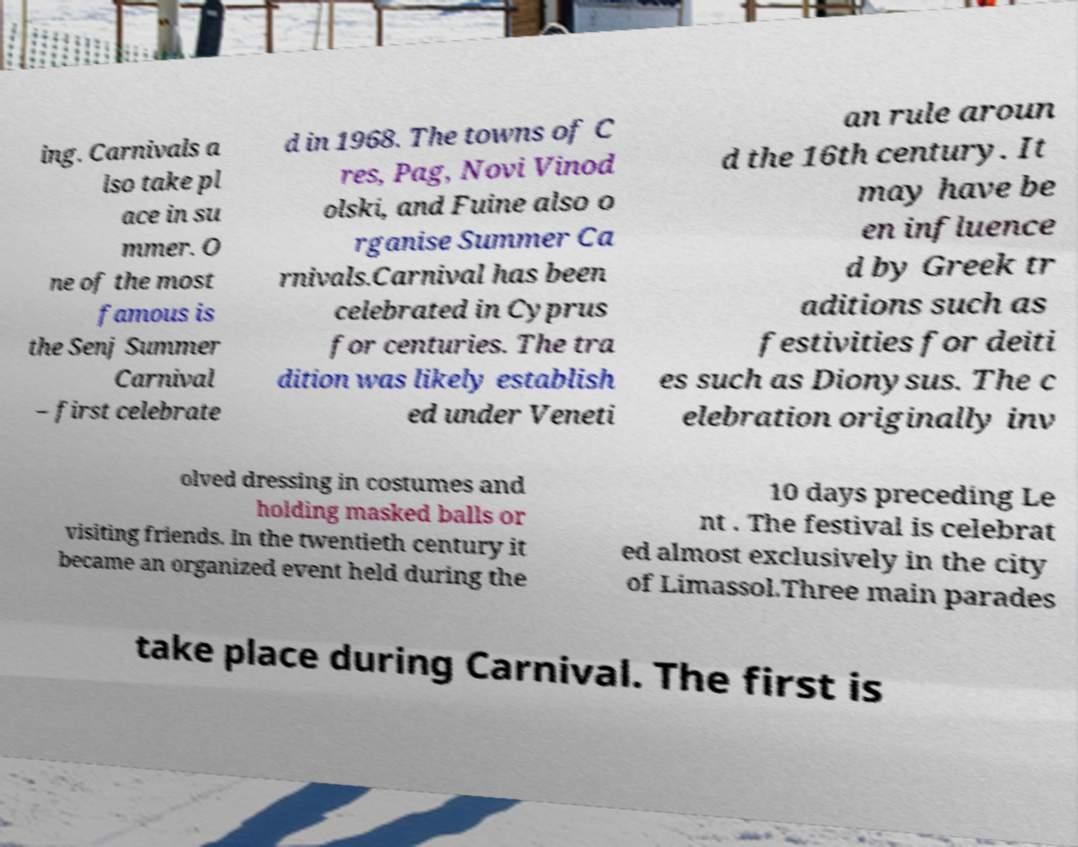Can you read and provide the text displayed in the image?This photo seems to have some interesting text. Can you extract and type it out for me? ing. Carnivals a lso take pl ace in su mmer. O ne of the most famous is the Senj Summer Carnival – first celebrate d in 1968. The towns of C res, Pag, Novi Vinod olski, and Fuine also o rganise Summer Ca rnivals.Carnival has been celebrated in Cyprus for centuries. The tra dition was likely establish ed under Veneti an rule aroun d the 16th century. It may have be en influence d by Greek tr aditions such as festivities for deiti es such as Dionysus. The c elebration originally inv olved dressing in costumes and holding masked balls or visiting friends. In the twentieth century it became an organized event held during the 10 days preceding Le nt . The festival is celebrat ed almost exclusively in the city of Limassol.Three main parades take place during Carnival. The first is 